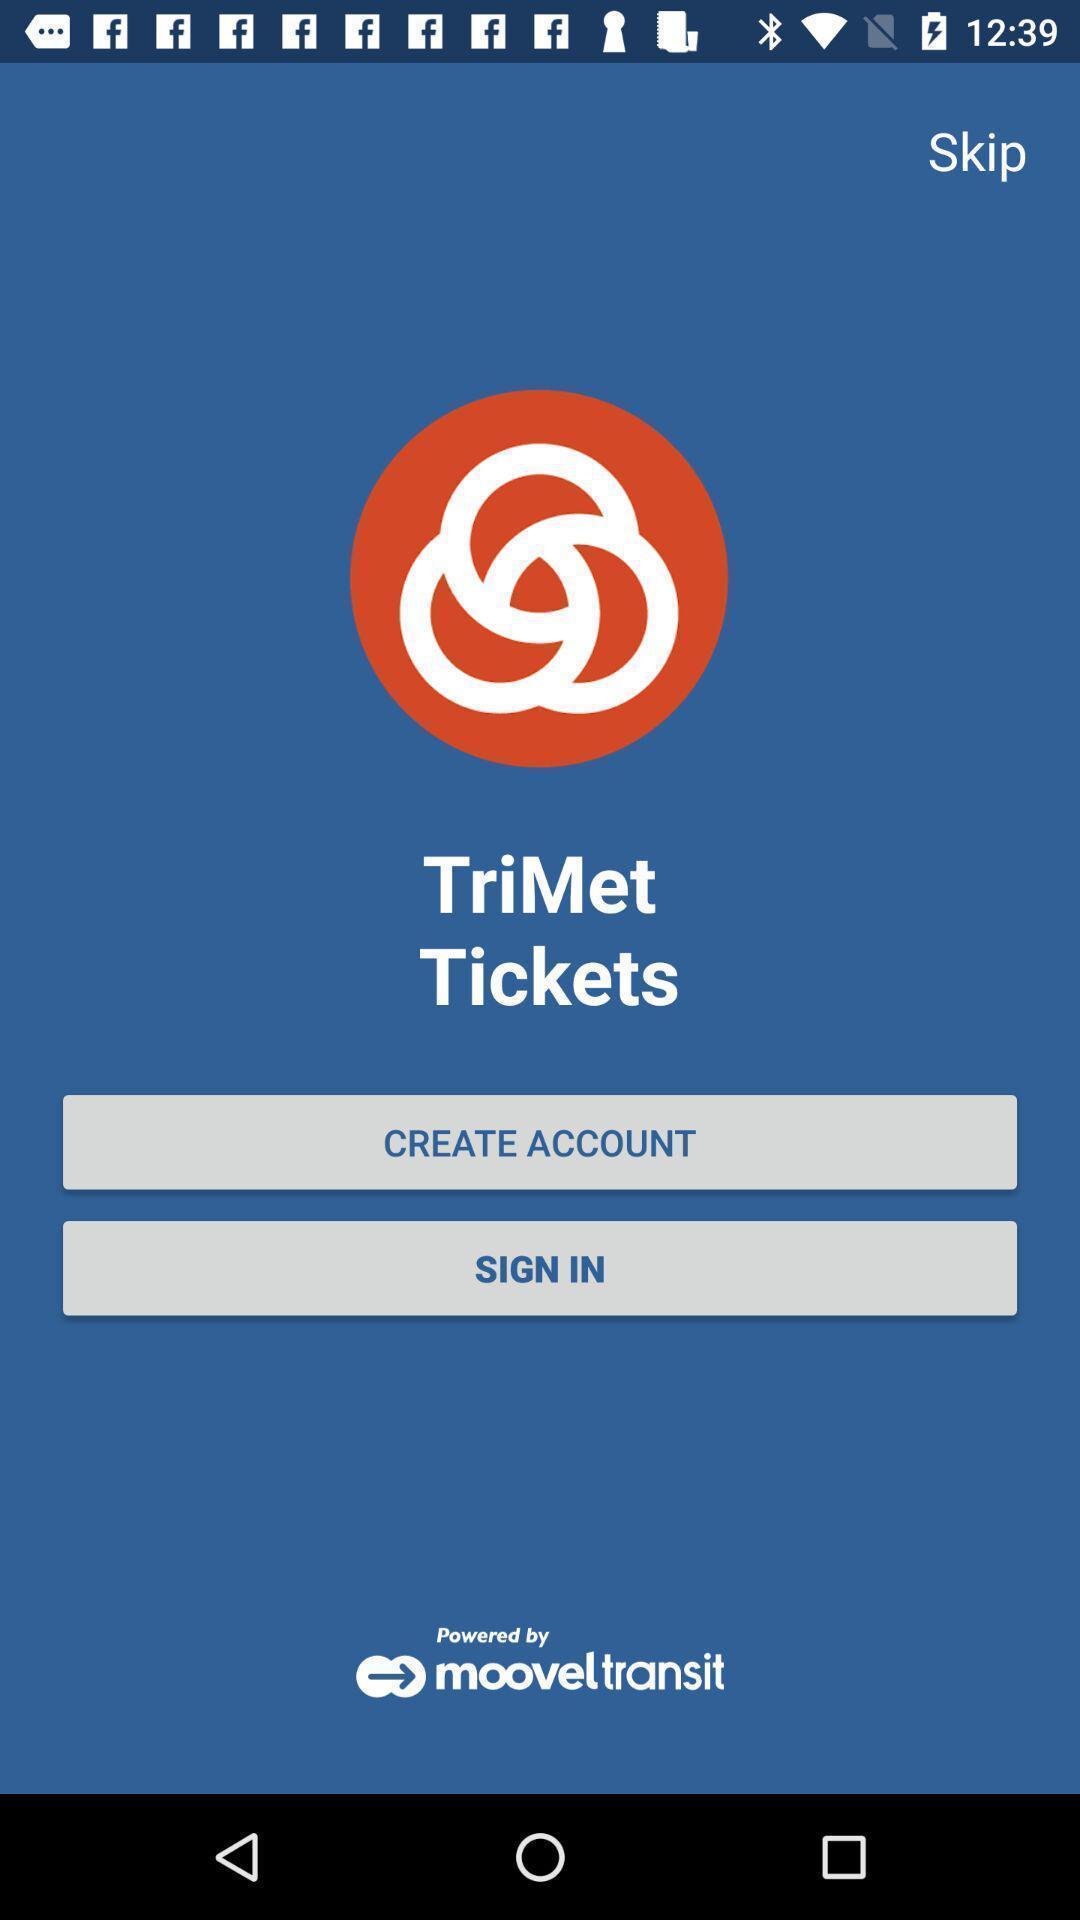Explain the elements present in this screenshot. Sign in page of an e-ticketing app. 